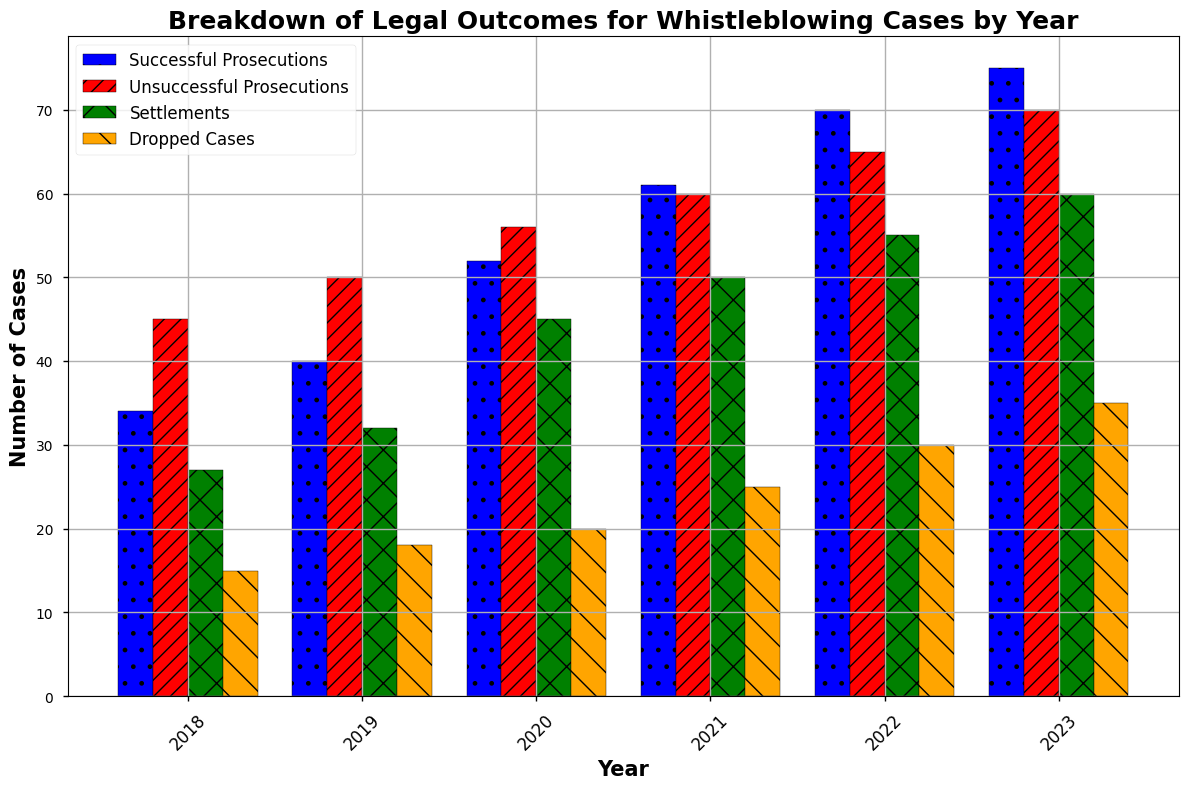Which year had the highest number of successful prosecutions? Look for the tallest blue bar labeled "Successful Prosecutions" in the figure. The highest number of successful prosecutions is in 2023.
Answer: 2023 Compare the number of dropped cases in 2018 and 2023. Which year had fewer dropped cases? Look at the length of the orange bars labeled "Dropped Cases" for 2018 and 2023. In 2018, it is 15, and in 2023, it is 35. So, 2018 had fewer dropped cases.
Answer: 2018 What is the difference in the number of settlements between 2021 and 2022? Check the green bars labeled "Settlements" for 2021 and 2022. Subtract the number for 2021 (50) from the number for 2022 (55). The difference is 55 - 50 = 5.
Answer: 5 Which year had the least number of unsuccessful prosecutions? Look at the red bars labeled "Unsuccessful Prosecutions" across all the years. The shortest bar is in 2018, with 45 unsuccessful prosecutions.
Answer: 2018 What is the combined number of successful and unsuccessful prosecutions for the year 2020? For the year 2020, sum the heights of the blue and red bars. Successful prosecutions are 52, and unsuccessful prosecutions are 56. Combined, this is 52 + 56 = 108.
Answer: 108 How did the number of dropped cases change from 2018 to 2023? Compare the height of the orange bars for "Dropped Cases" in 2018 (15) and 2023 (35). The change is 35 - 15 = 20. Therefore, the number of dropped cases increased by 20.
Answer: Increased by 20 In which year did the number of unsuccessful prosecutions equal the number of settlements? Compare the length of red and green bars labeled "Unsuccessful Prosecutions" and "Settlements" respectively. In 2023, both bars are equal, with a value of 60.
Answer: 2023 Calculate the total number of legal outcomes (sum of all categories) in 2021. Add the values for all categories in 2021: 61 (successful prosecutions) + 60 (unsuccessful prosecutions) + 50 (settlements) + 25 (dropped cases). This sums to 61 + 60 + 50 + 25 = 196.
Answer: 196 